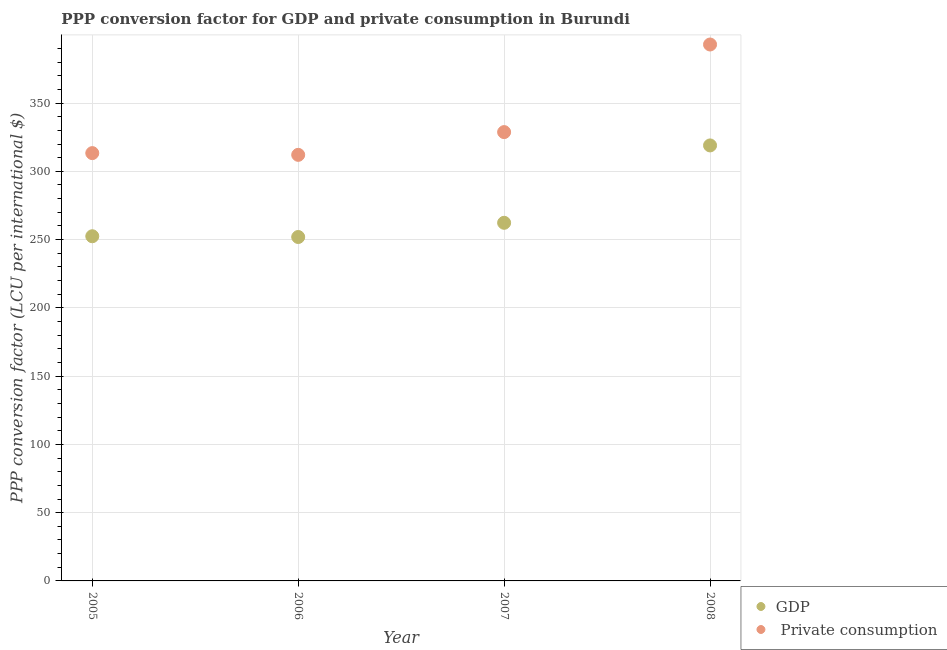What is the ppp conversion factor for gdp in 2007?
Offer a very short reply. 262.31. Across all years, what is the maximum ppp conversion factor for gdp?
Offer a terse response. 318.99. Across all years, what is the minimum ppp conversion factor for private consumption?
Give a very brief answer. 312.09. In which year was the ppp conversion factor for private consumption maximum?
Your response must be concise. 2008. What is the total ppp conversion factor for gdp in the graph?
Keep it short and to the point. 1085.67. What is the difference between the ppp conversion factor for private consumption in 2005 and that in 2007?
Your response must be concise. -15.39. What is the difference between the ppp conversion factor for gdp in 2005 and the ppp conversion factor for private consumption in 2008?
Keep it short and to the point. -140.45. What is the average ppp conversion factor for private consumption per year?
Your answer should be compact. 336.77. In the year 2007, what is the difference between the ppp conversion factor for gdp and ppp conversion factor for private consumption?
Make the answer very short. -66.43. In how many years, is the ppp conversion factor for private consumption greater than 340 LCU?
Ensure brevity in your answer.  1. What is the ratio of the ppp conversion factor for private consumption in 2005 to that in 2007?
Give a very brief answer. 0.95. Is the ppp conversion factor for gdp in 2006 less than that in 2007?
Your answer should be very brief. Yes. What is the difference between the highest and the second highest ppp conversion factor for private consumption?
Give a very brief answer. 64.17. What is the difference between the highest and the lowest ppp conversion factor for gdp?
Provide a short and direct response. 67.08. Is the sum of the ppp conversion factor for gdp in 2005 and 2008 greater than the maximum ppp conversion factor for private consumption across all years?
Ensure brevity in your answer.  Yes. Does the ppp conversion factor for private consumption monotonically increase over the years?
Keep it short and to the point. No. How many dotlines are there?
Offer a terse response. 2. What is the difference between two consecutive major ticks on the Y-axis?
Make the answer very short. 50. Does the graph contain any zero values?
Your response must be concise. No. Does the graph contain grids?
Keep it short and to the point. Yes. Where does the legend appear in the graph?
Offer a very short reply. Bottom right. How many legend labels are there?
Provide a succinct answer. 2. What is the title of the graph?
Offer a terse response. PPP conversion factor for GDP and private consumption in Burundi. Does "Electricity and heat production" appear as one of the legend labels in the graph?
Offer a terse response. No. What is the label or title of the X-axis?
Provide a short and direct response. Year. What is the label or title of the Y-axis?
Give a very brief answer. PPP conversion factor (LCU per international $). What is the PPP conversion factor (LCU per international $) in GDP in 2005?
Your response must be concise. 252.46. What is the PPP conversion factor (LCU per international $) of  Private consumption in 2005?
Your answer should be compact. 313.35. What is the PPP conversion factor (LCU per international $) of GDP in 2006?
Provide a short and direct response. 251.91. What is the PPP conversion factor (LCU per international $) of  Private consumption in 2006?
Give a very brief answer. 312.09. What is the PPP conversion factor (LCU per international $) in GDP in 2007?
Your answer should be very brief. 262.31. What is the PPP conversion factor (LCU per international $) in  Private consumption in 2007?
Ensure brevity in your answer.  328.74. What is the PPP conversion factor (LCU per international $) in GDP in 2008?
Make the answer very short. 318.99. What is the PPP conversion factor (LCU per international $) in  Private consumption in 2008?
Provide a succinct answer. 392.91. Across all years, what is the maximum PPP conversion factor (LCU per international $) of GDP?
Keep it short and to the point. 318.99. Across all years, what is the maximum PPP conversion factor (LCU per international $) in  Private consumption?
Provide a short and direct response. 392.91. Across all years, what is the minimum PPP conversion factor (LCU per international $) of GDP?
Offer a terse response. 251.91. Across all years, what is the minimum PPP conversion factor (LCU per international $) of  Private consumption?
Ensure brevity in your answer.  312.09. What is the total PPP conversion factor (LCU per international $) of GDP in the graph?
Provide a succinct answer. 1085.67. What is the total PPP conversion factor (LCU per international $) of  Private consumption in the graph?
Your answer should be very brief. 1347.1. What is the difference between the PPP conversion factor (LCU per international $) in GDP in 2005 and that in 2006?
Your response must be concise. 0.56. What is the difference between the PPP conversion factor (LCU per international $) in  Private consumption in 2005 and that in 2006?
Your response must be concise. 1.27. What is the difference between the PPP conversion factor (LCU per international $) in GDP in 2005 and that in 2007?
Make the answer very short. -9.85. What is the difference between the PPP conversion factor (LCU per international $) in  Private consumption in 2005 and that in 2007?
Offer a very short reply. -15.39. What is the difference between the PPP conversion factor (LCU per international $) in GDP in 2005 and that in 2008?
Ensure brevity in your answer.  -66.52. What is the difference between the PPP conversion factor (LCU per international $) in  Private consumption in 2005 and that in 2008?
Your answer should be very brief. -79.56. What is the difference between the PPP conversion factor (LCU per international $) in GDP in 2006 and that in 2007?
Offer a terse response. -10.41. What is the difference between the PPP conversion factor (LCU per international $) in  Private consumption in 2006 and that in 2007?
Offer a very short reply. -16.66. What is the difference between the PPP conversion factor (LCU per international $) of GDP in 2006 and that in 2008?
Give a very brief answer. -67.08. What is the difference between the PPP conversion factor (LCU per international $) in  Private consumption in 2006 and that in 2008?
Offer a very short reply. -80.82. What is the difference between the PPP conversion factor (LCU per international $) of GDP in 2007 and that in 2008?
Make the answer very short. -56.67. What is the difference between the PPP conversion factor (LCU per international $) of  Private consumption in 2007 and that in 2008?
Keep it short and to the point. -64.17. What is the difference between the PPP conversion factor (LCU per international $) of GDP in 2005 and the PPP conversion factor (LCU per international $) of  Private consumption in 2006?
Provide a succinct answer. -59.62. What is the difference between the PPP conversion factor (LCU per international $) in GDP in 2005 and the PPP conversion factor (LCU per international $) in  Private consumption in 2007?
Give a very brief answer. -76.28. What is the difference between the PPP conversion factor (LCU per international $) of GDP in 2005 and the PPP conversion factor (LCU per international $) of  Private consumption in 2008?
Offer a very short reply. -140.45. What is the difference between the PPP conversion factor (LCU per international $) of GDP in 2006 and the PPP conversion factor (LCU per international $) of  Private consumption in 2007?
Provide a succinct answer. -76.84. What is the difference between the PPP conversion factor (LCU per international $) in GDP in 2006 and the PPP conversion factor (LCU per international $) in  Private consumption in 2008?
Offer a very short reply. -141. What is the difference between the PPP conversion factor (LCU per international $) in GDP in 2007 and the PPP conversion factor (LCU per international $) in  Private consumption in 2008?
Offer a terse response. -130.6. What is the average PPP conversion factor (LCU per international $) of GDP per year?
Provide a short and direct response. 271.42. What is the average PPP conversion factor (LCU per international $) of  Private consumption per year?
Provide a short and direct response. 336.77. In the year 2005, what is the difference between the PPP conversion factor (LCU per international $) of GDP and PPP conversion factor (LCU per international $) of  Private consumption?
Your answer should be very brief. -60.89. In the year 2006, what is the difference between the PPP conversion factor (LCU per international $) of GDP and PPP conversion factor (LCU per international $) of  Private consumption?
Give a very brief answer. -60.18. In the year 2007, what is the difference between the PPP conversion factor (LCU per international $) of GDP and PPP conversion factor (LCU per international $) of  Private consumption?
Offer a very short reply. -66.43. In the year 2008, what is the difference between the PPP conversion factor (LCU per international $) of GDP and PPP conversion factor (LCU per international $) of  Private consumption?
Keep it short and to the point. -73.92. What is the ratio of the PPP conversion factor (LCU per international $) of  Private consumption in 2005 to that in 2006?
Keep it short and to the point. 1. What is the ratio of the PPP conversion factor (LCU per international $) of GDP in 2005 to that in 2007?
Your response must be concise. 0.96. What is the ratio of the PPP conversion factor (LCU per international $) of  Private consumption in 2005 to that in 2007?
Give a very brief answer. 0.95. What is the ratio of the PPP conversion factor (LCU per international $) in GDP in 2005 to that in 2008?
Make the answer very short. 0.79. What is the ratio of the PPP conversion factor (LCU per international $) of  Private consumption in 2005 to that in 2008?
Give a very brief answer. 0.8. What is the ratio of the PPP conversion factor (LCU per international $) in GDP in 2006 to that in 2007?
Ensure brevity in your answer.  0.96. What is the ratio of the PPP conversion factor (LCU per international $) of  Private consumption in 2006 to that in 2007?
Ensure brevity in your answer.  0.95. What is the ratio of the PPP conversion factor (LCU per international $) of GDP in 2006 to that in 2008?
Keep it short and to the point. 0.79. What is the ratio of the PPP conversion factor (LCU per international $) of  Private consumption in 2006 to that in 2008?
Make the answer very short. 0.79. What is the ratio of the PPP conversion factor (LCU per international $) in GDP in 2007 to that in 2008?
Your response must be concise. 0.82. What is the ratio of the PPP conversion factor (LCU per international $) in  Private consumption in 2007 to that in 2008?
Your answer should be very brief. 0.84. What is the difference between the highest and the second highest PPP conversion factor (LCU per international $) in GDP?
Your response must be concise. 56.67. What is the difference between the highest and the second highest PPP conversion factor (LCU per international $) of  Private consumption?
Give a very brief answer. 64.17. What is the difference between the highest and the lowest PPP conversion factor (LCU per international $) of GDP?
Your response must be concise. 67.08. What is the difference between the highest and the lowest PPP conversion factor (LCU per international $) of  Private consumption?
Give a very brief answer. 80.82. 